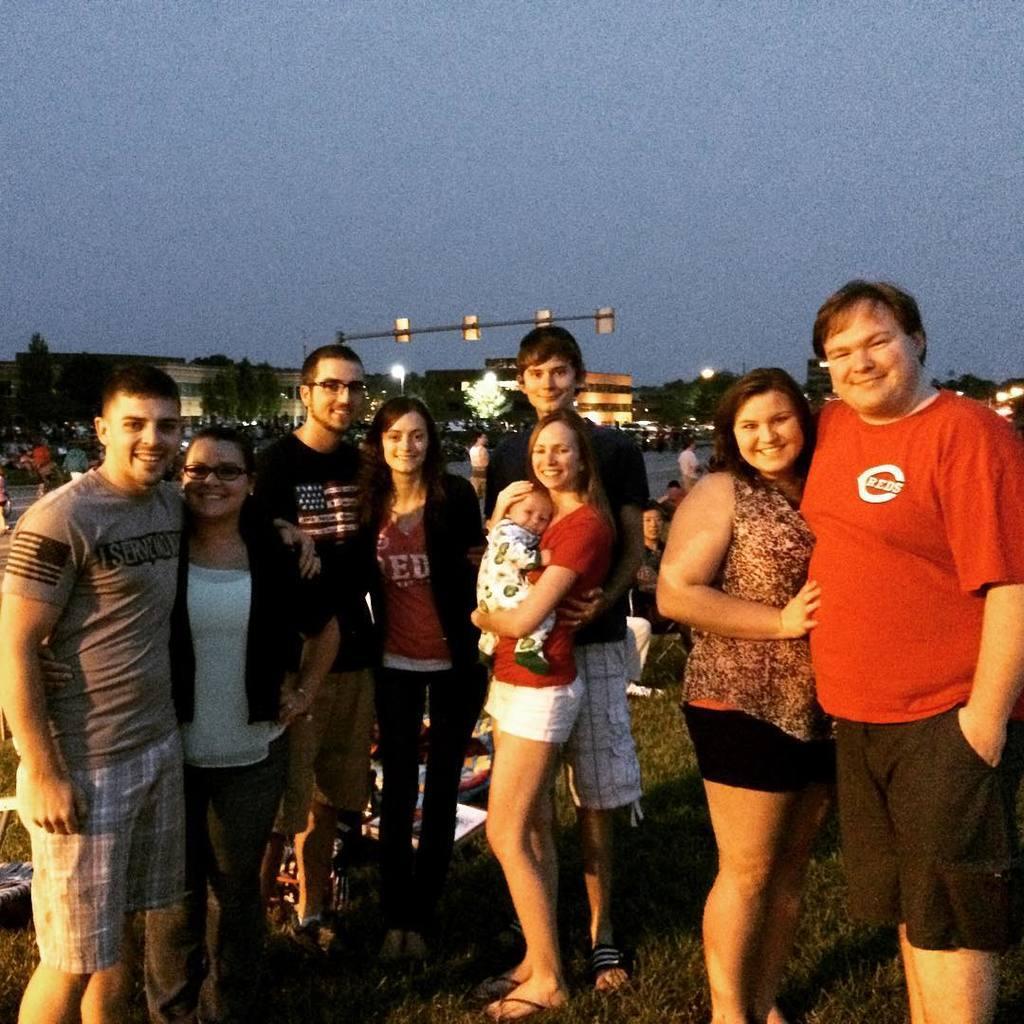In one or two sentences, can you explain what this image depicts? In this image we can see a group of people standing. In that a woman is carrying a baby. We can also see grass, some objects placed on the ground and some people sitting. On the backside we can see a group of people, buildings, water, poles, lights, a group of trees and the sky which looks cloudy. 